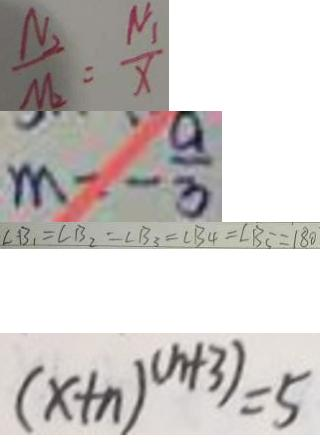<formula> <loc_0><loc_0><loc_500><loc_500>\frac { N _ { 2 } } { M _ { 2 } } = \frac { N _ { 1 } } { x } 
 m = - \frac { a } { 3 } 
 \angle B _ { 1 } = \angle B _ { 2 } = \angle B _ { 3 } = \angle B _ { 4 } = \angle B _ { 5 } = 1 8 0 
 ( x + n ) ^ { ( n + 3 ) } = 5</formula> 